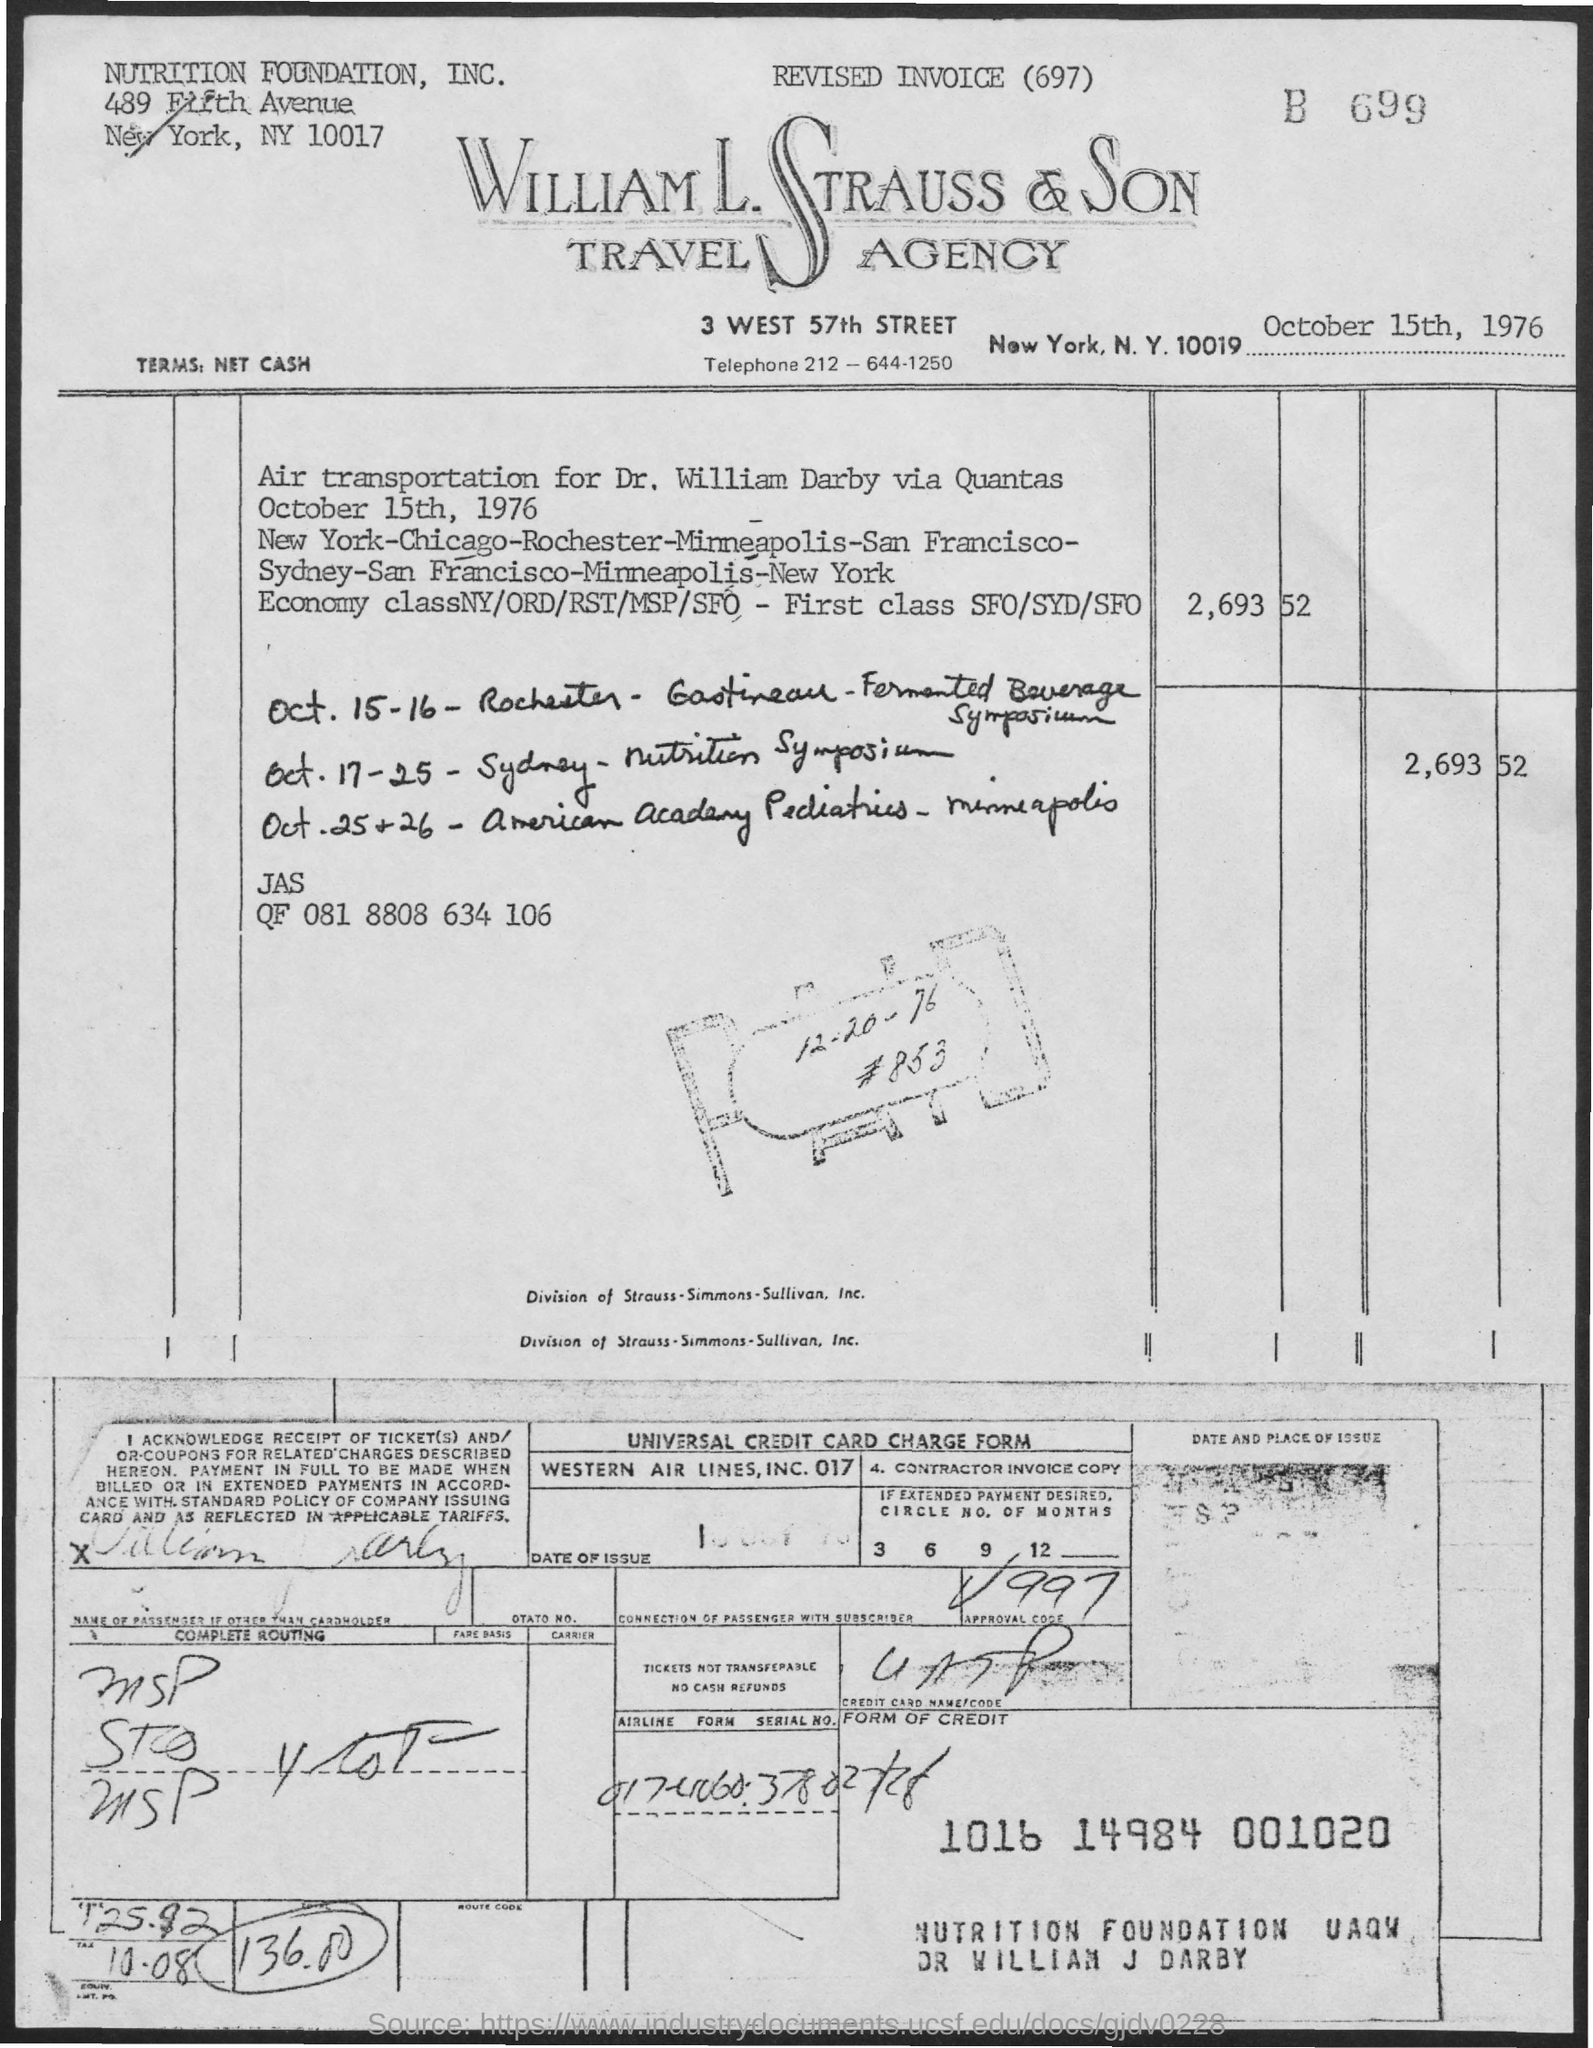Indicate a few pertinent items in this graphic. The telephone number is 212-644-1250. The date mentioned at the top of the document is October 15th, 1976. 